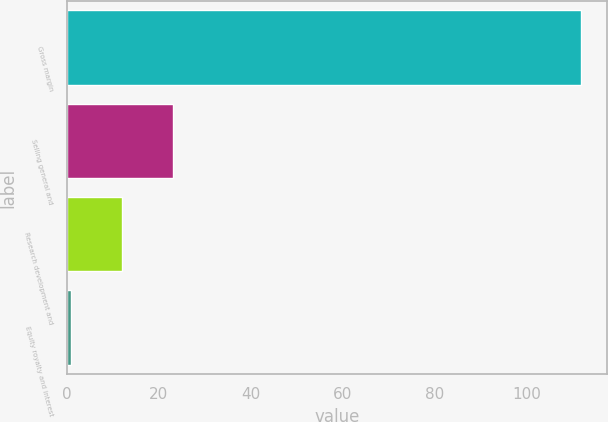Convert chart. <chart><loc_0><loc_0><loc_500><loc_500><bar_chart><fcel>Gross margin<fcel>Selling general and<fcel>Research development and<fcel>Equity royalty and interest<nl><fcel>112<fcel>23.2<fcel>12.1<fcel>1<nl></chart> 